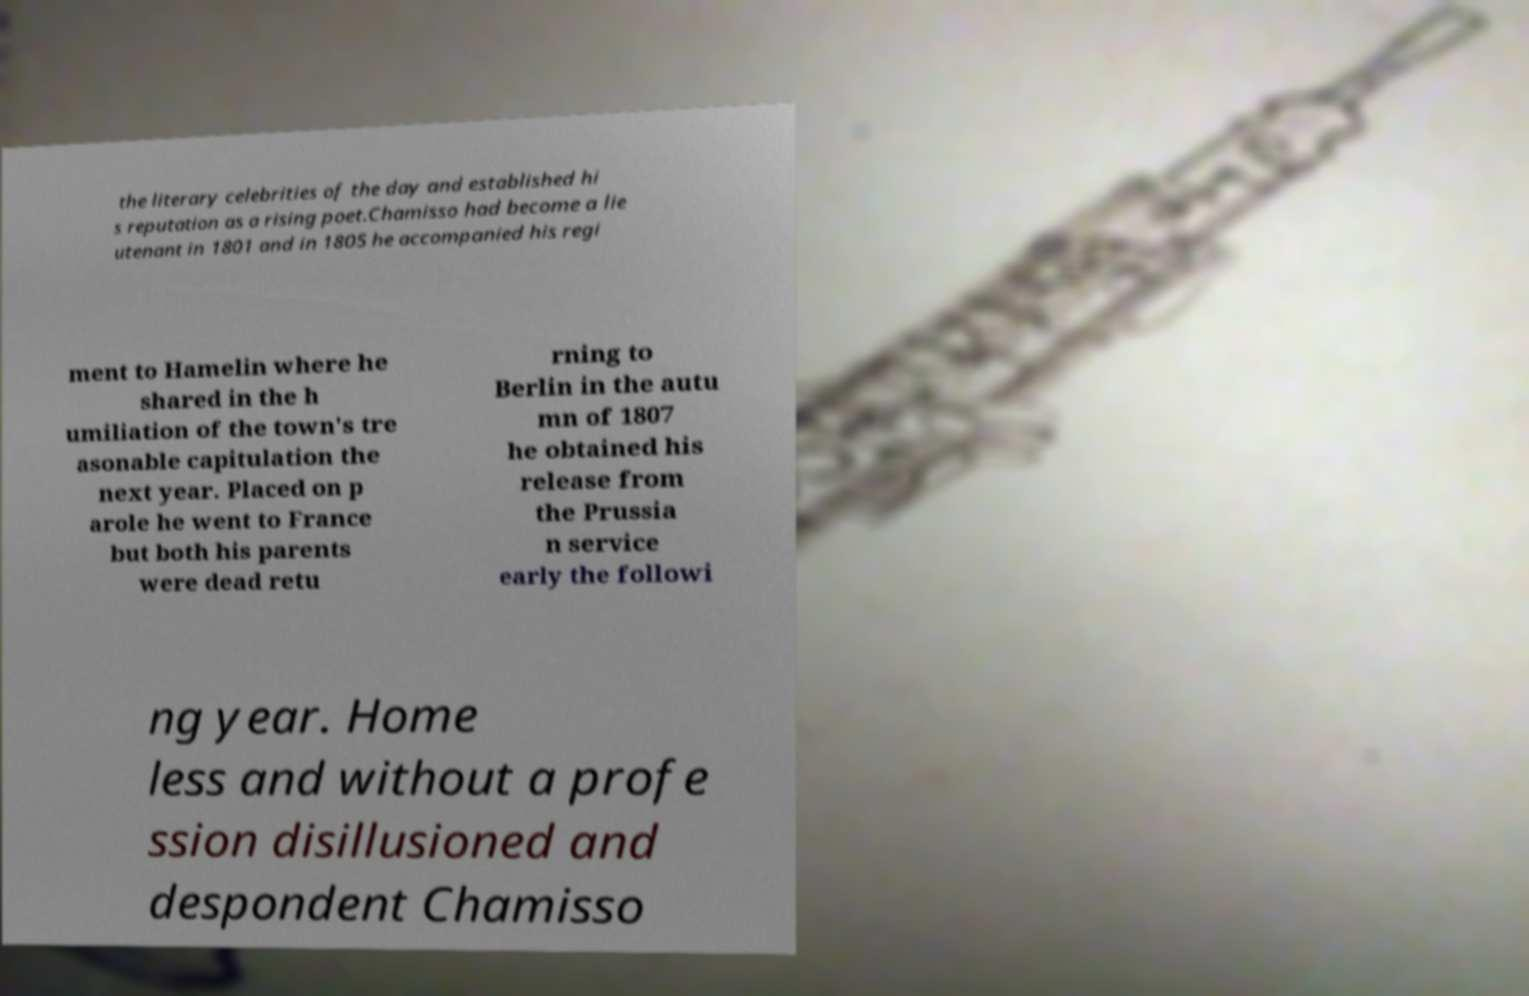Could you assist in decoding the text presented in this image and type it out clearly? the literary celebrities of the day and established hi s reputation as a rising poet.Chamisso had become a lie utenant in 1801 and in 1805 he accompanied his regi ment to Hamelin where he shared in the h umiliation of the town's tre asonable capitulation the next year. Placed on p arole he went to France but both his parents were dead retu rning to Berlin in the autu mn of 1807 he obtained his release from the Prussia n service early the followi ng year. Home less and without a profe ssion disillusioned and despondent Chamisso 